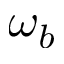Convert formula to latex. <formula><loc_0><loc_0><loc_500><loc_500>\omega _ { b }</formula> 